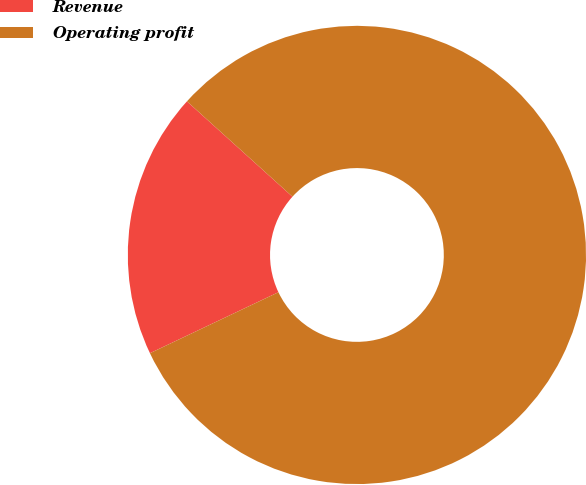<chart> <loc_0><loc_0><loc_500><loc_500><pie_chart><fcel>Revenue<fcel>Operating profit<nl><fcel>18.75%<fcel>81.25%<nl></chart> 